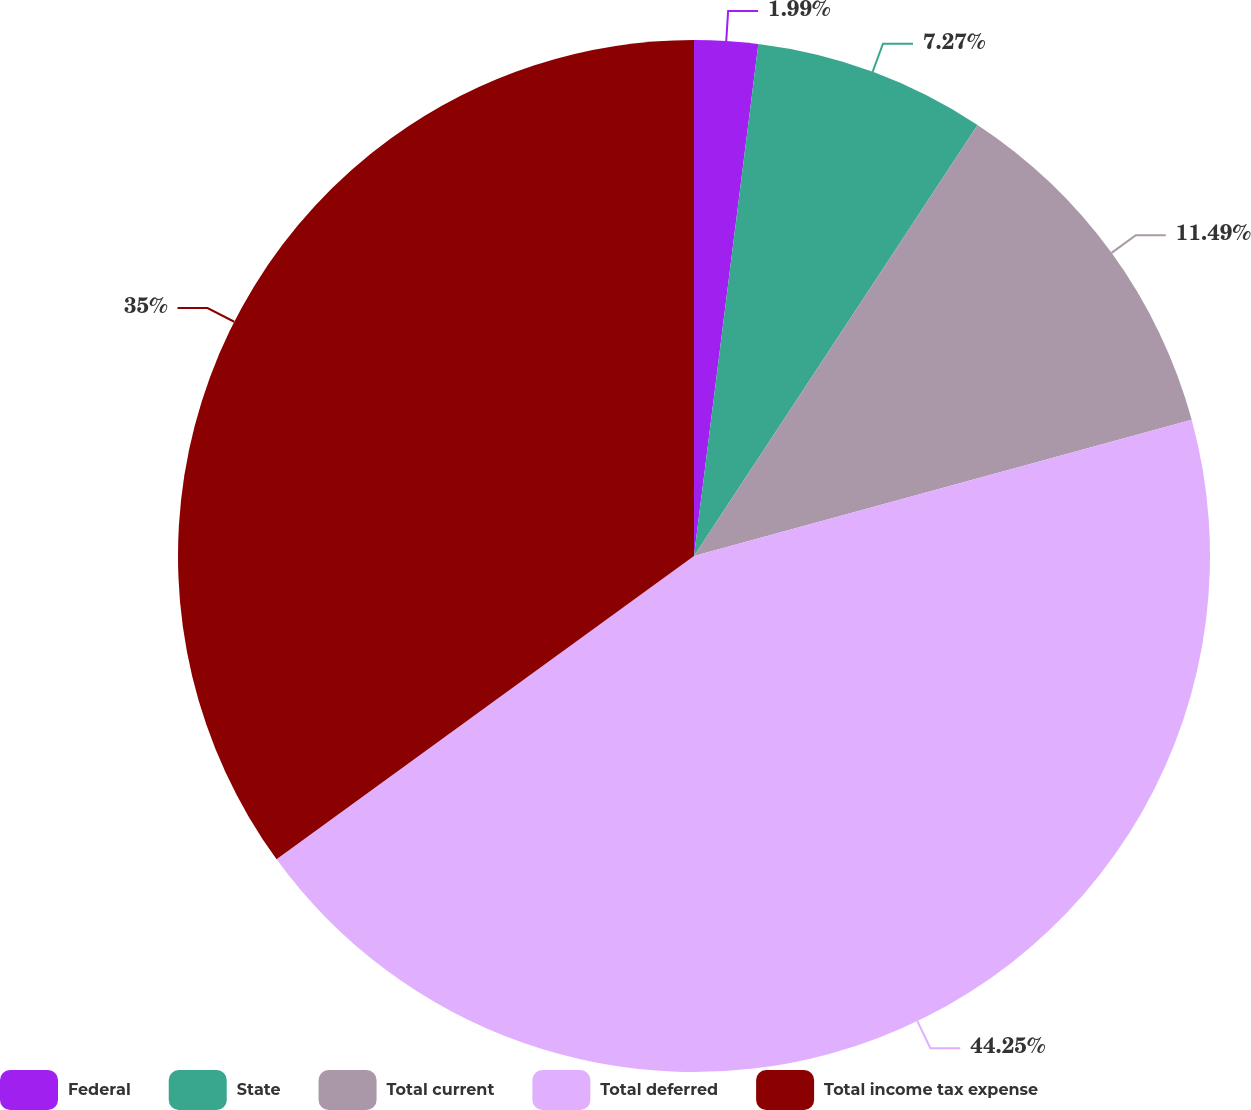<chart> <loc_0><loc_0><loc_500><loc_500><pie_chart><fcel>Federal<fcel>State<fcel>Total current<fcel>Total deferred<fcel>Total income tax expense<nl><fcel>1.99%<fcel>7.27%<fcel>11.49%<fcel>44.25%<fcel>35.0%<nl></chart> 